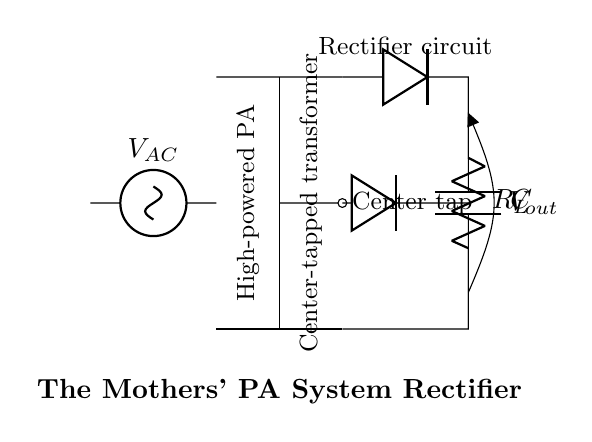What type of transformer is used in this circuit? The circuit uses a center-tapped transformer, which is indicated by the label "Center tap" and the configuration in the drawing where the transformer has a central connection.
Answer: Center-tapped What is the load resistor labeled in the circuit? The load resistor is labeled as "R_L" and is located at the output side of the diodes, indicating where the current flows out of the rectifier.
Answer: R_L How many diodes are present in the circuit? There are two diodes in the circuit. One is connected to the upper terminal of the transformer, while the other is connected to the central tap, forming a full-wave rectification setup.
Answer: Two What is the function of the capacitor in this circuit? The capacitor, labeled "C", is used for smoothing the output voltage by filtering out the ripple produced by the rectification process, which results in a more stable DC voltage.
Answer: Smoothing What is the output voltage labeled in this circuit? The output voltage is labeled as "V_out", which is the resultant voltage available across the load resistor after rectification, demonstrating the voltage output from the circuit.
Answer: V_out How does the center-tapped transformer affect the output voltage? The center-tapped transformer allows for full-wave rectification, meaning that the output voltage can be approximately double that of a single diode rectifier, as it combines both halves of the AC waveform when rectified.
Answer: Doubled 